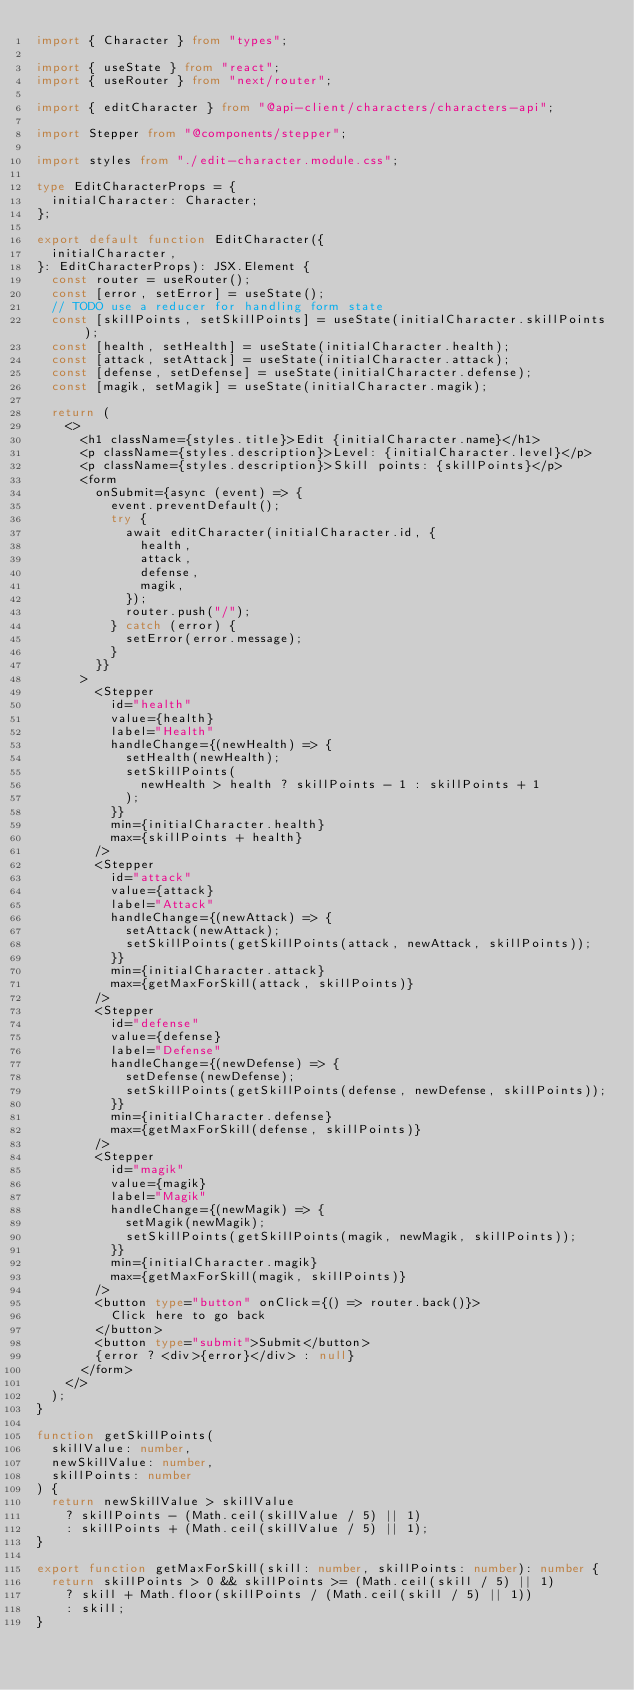<code> <loc_0><loc_0><loc_500><loc_500><_TypeScript_>import { Character } from "types";

import { useState } from "react";
import { useRouter } from "next/router";

import { editCharacter } from "@api-client/characters/characters-api";

import Stepper from "@components/stepper";

import styles from "./edit-character.module.css";

type EditCharacterProps = {
  initialCharacter: Character;
};

export default function EditCharacter({
  initialCharacter,
}: EditCharacterProps): JSX.Element {
  const router = useRouter();
  const [error, setError] = useState();
  // TODO use a reducer for handling form state
  const [skillPoints, setSkillPoints] = useState(initialCharacter.skillPoints);
  const [health, setHealth] = useState(initialCharacter.health);
  const [attack, setAttack] = useState(initialCharacter.attack);
  const [defense, setDefense] = useState(initialCharacter.defense);
  const [magik, setMagik] = useState(initialCharacter.magik);

  return (
    <>
      <h1 className={styles.title}>Edit {initialCharacter.name}</h1>
      <p className={styles.description}>Level: {initialCharacter.level}</p>
      <p className={styles.description}>Skill points: {skillPoints}</p>
      <form
        onSubmit={async (event) => {
          event.preventDefault();
          try {
            await editCharacter(initialCharacter.id, {
              health,
              attack,
              defense,
              magik,
            });
            router.push("/");
          } catch (error) {
            setError(error.message);
          }
        }}
      >
        <Stepper
          id="health"
          value={health}
          label="Health"
          handleChange={(newHealth) => {
            setHealth(newHealth);
            setSkillPoints(
              newHealth > health ? skillPoints - 1 : skillPoints + 1
            );
          }}
          min={initialCharacter.health}
          max={skillPoints + health}
        />
        <Stepper
          id="attack"
          value={attack}
          label="Attack"
          handleChange={(newAttack) => {
            setAttack(newAttack);
            setSkillPoints(getSkillPoints(attack, newAttack, skillPoints));
          }}
          min={initialCharacter.attack}
          max={getMaxForSkill(attack, skillPoints)}
        />
        <Stepper
          id="defense"
          value={defense}
          label="Defense"
          handleChange={(newDefense) => {
            setDefense(newDefense);
            setSkillPoints(getSkillPoints(defense, newDefense, skillPoints));
          }}
          min={initialCharacter.defense}
          max={getMaxForSkill(defense, skillPoints)}
        />
        <Stepper
          id="magik"
          value={magik}
          label="Magik"
          handleChange={(newMagik) => {
            setMagik(newMagik);
            setSkillPoints(getSkillPoints(magik, newMagik, skillPoints));
          }}
          min={initialCharacter.magik}
          max={getMaxForSkill(magik, skillPoints)}
        />
        <button type="button" onClick={() => router.back()}>
          Click here to go back
        </button>
        <button type="submit">Submit</button>
        {error ? <div>{error}</div> : null}
      </form>
    </>
  );
}

function getSkillPoints(
  skillValue: number,
  newSkillValue: number,
  skillPoints: number
) {
  return newSkillValue > skillValue
    ? skillPoints - (Math.ceil(skillValue / 5) || 1)
    : skillPoints + (Math.ceil(skillValue / 5) || 1);
}

export function getMaxForSkill(skill: number, skillPoints: number): number {
  return skillPoints > 0 && skillPoints >= (Math.ceil(skill / 5) || 1)
    ? skill + Math.floor(skillPoints / (Math.ceil(skill / 5) || 1))
    : skill;
}
</code> 